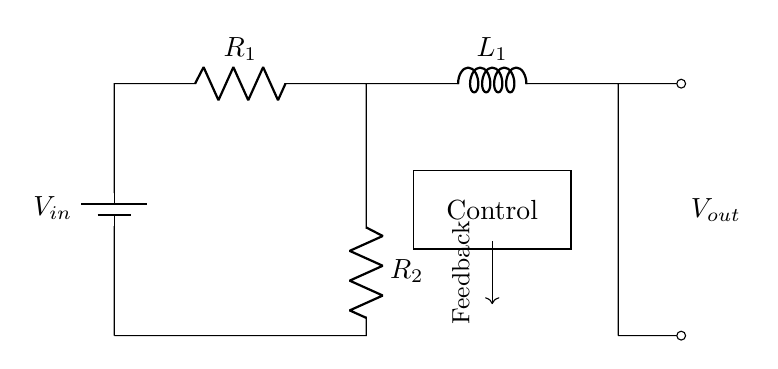What is the input voltage of the circuit? The input voltage is labeled as V_in in the circuit, which indicates the source voltage supplying the circuit.
Answer: V_in What components are used in the circuit? The components include a battery (V_in), two resistors (R_1, R_2), one inductor (L_1), and a control element for feedback.
Answer: Battery, Resistors, Inductor What is the purpose of the control block in this circuit? The control block is designed to manage the feedback mechanism, allowing the circuit to adjust the voltage output based on input conditions.
Answer: Feedback control What is the output voltage from this configuration? The output voltage is indicated as V_out in the circuit, which reflects the regulated output voltage after passing through the resistors and inductor.
Answer: V_out How many resistors are present in the circuit? There are two resistors labeled R_1 and R_2 in the circuit diagram.
Answer: Two What is the role of the inductor in this RL-based voltage regulator circuit? The inductor (L_1) stores energy in a magnetic field when current passes through it, which helps to smooth out fluctuations in current and stabilize the output voltage.
Answer: Energy storage Can you explain how the feedback influences the output? The feedback mechanism allows the output voltage V_out to be monitored and compared against a reference value, enabling the control system to adjust R_2 or the inductor L_1 if the output deviates from the desired level, ensuring stability in long-duration applications.
Answer: Stabilizes output through feedback 